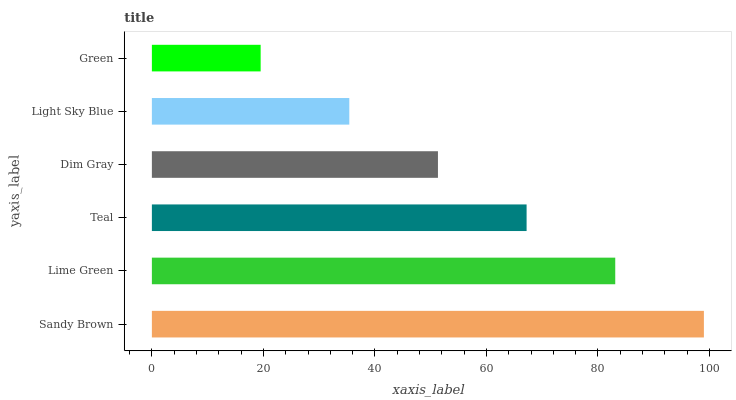Is Green the minimum?
Answer yes or no. Yes. Is Sandy Brown the maximum?
Answer yes or no. Yes. Is Lime Green the minimum?
Answer yes or no. No. Is Lime Green the maximum?
Answer yes or no. No. Is Sandy Brown greater than Lime Green?
Answer yes or no. Yes. Is Lime Green less than Sandy Brown?
Answer yes or no. Yes. Is Lime Green greater than Sandy Brown?
Answer yes or no. No. Is Sandy Brown less than Lime Green?
Answer yes or no. No. Is Teal the high median?
Answer yes or no. Yes. Is Dim Gray the low median?
Answer yes or no. Yes. Is Light Sky Blue the high median?
Answer yes or no. No. Is Lime Green the low median?
Answer yes or no. No. 